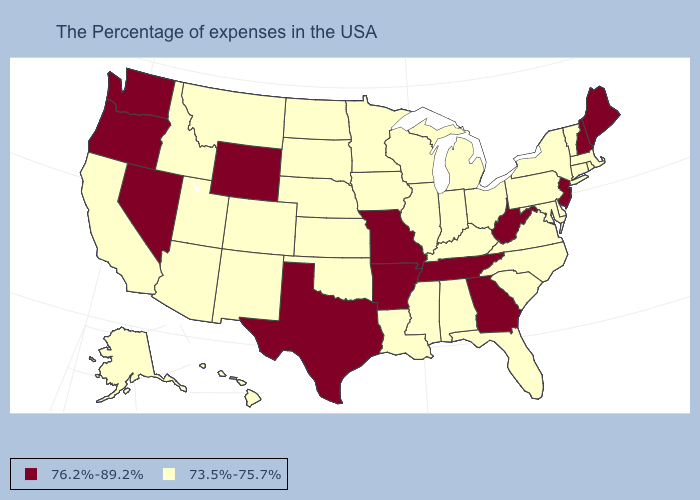What is the value of Ohio?
Answer briefly. 73.5%-75.7%. Which states have the lowest value in the USA?
Quick response, please. Massachusetts, Rhode Island, Vermont, Connecticut, New York, Delaware, Maryland, Pennsylvania, Virginia, North Carolina, South Carolina, Ohio, Florida, Michigan, Kentucky, Indiana, Alabama, Wisconsin, Illinois, Mississippi, Louisiana, Minnesota, Iowa, Kansas, Nebraska, Oklahoma, South Dakota, North Dakota, Colorado, New Mexico, Utah, Montana, Arizona, Idaho, California, Alaska, Hawaii. Name the states that have a value in the range 73.5%-75.7%?
Concise answer only. Massachusetts, Rhode Island, Vermont, Connecticut, New York, Delaware, Maryland, Pennsylvania, Virginia, North Carolina, South Carolina, Ohio, Florida, Michigan, Kentucky, Indiana, Alabama, Wisconsin, Illinois, Mississippi, Louisiana, Minnesota, Iowa, Kansas, Nebraska, Oklahoma, South Dakota, North Dakota, Colorado, New Mexico, Utah, Montana, Arizona, Idaho, California, Alaska, Hawaii. Does the first symbol in the legend represent the smallest category?
Give a very brief answer. No. Among the states that border Texas , which have the highest value?
Write a very short answer. Arkansas. Among the states that border Colorado , which have the lowest value?
Short answer required. Kansas, Nebraska, Oklahoma, New Mexico, Utah, Arizona. Name the states that have a value in the range 73.5%-75.7%?
Quick response, please. Massachusetts, Rhode Island, Vermont, Connecticut, New York, Delaware, Maryland, Pennsylvania, Virginia, North Carolina, South Carolina, Ohio, Florida, Michigan, Kentucky, Indiana, Alabama, Wisconsin, Illinois, Mississippi, Louisiana, Minnesota, Iowa, Kansas, Nebraska, Oklahoma, South Dakota, North Dakota, Colorado, New Mexico, Utah, Montana, Arizona, Idaho, California, Alaska, Hawaii. What is the lowest value in the West?
Answer briefly. 73.5%-75.7%. What is the lowest value in states that border Iowa?
Give a very brief answer. 73.5%-75.7%. Does Minnesota have the lowest value in the MidWest?
Give a very brief answer. Yes. Does Texas have the lowest value in the USA?
Give a very brief answer. No. Is the legend a continuous bar?
Be succinct. No. Among the states that border Iowa , does South Dakota have the highest value?
Keep it brief. No. 